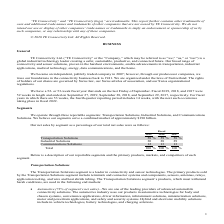According to Te Connectivity's financial document, What are the net sales by segment presented as a percentage of? percentage of our total net sales. The document states: "Our net sales by segment as a percentage of our total net sales were as follows:..." Also, How much does the company believe the Transportation, Industrial and Communications Solutions segments serve a combined market of? approximately $190 billion. The document states: "e believe our segments serve a combined market of approximately $190 billion...." Also, What are the three main segments that the company operates in? The document contains multiple relevant values: Transportation Solutions, Industrial Solutions, Communications Solutions. From the document: "Transportation Solutions 58 % 59 % 58 % Industrial Solutions 30 28 29 Communications Solutions 12 13 13..." Additionally, In which year was the percentage of industrial solutions the lowest in? According to the financial document, 2018. The relevant text states: "2019 2018 2017..." Also, can you calculate: What was the percentage change in Industrial Solutions in 2019 from 2018? Based on the calculation: 30-28, the result is 2 (percentage). This is based on the information: "Industrial Solutions 30 28 29 Industrial Solutions 30 28 29..." The key data points involved are: 28, 30. Also, can you calculate: What was the percentage change in Transportation Solutions in 2019 from 2018? Based on the calculation: 58-59, the result is -1 (percentage). This is based on the information: "Transportation Solutions 58 % 59 % 58 % Transportation Solutions 58 % 59 % 58 %..." The key data points involved are: 58, 59. 